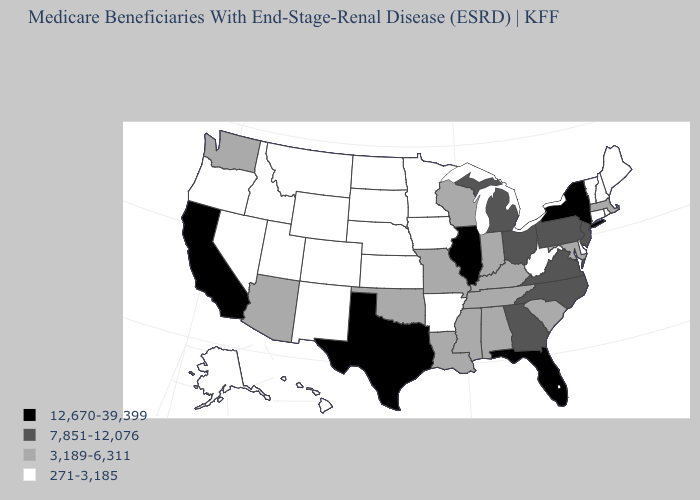Name the states that have a value in the range 271-3,185?
Concise answer only. Alaska, Arkansas, Colorado, Connecticut, Delaware, Hawaii, Idaho, Iowa, Kansas, Maine, Minnesota, Montana, Nebraska, Nevada, New Hampshire, New Mexico, North Dakota, Oregon, Rhode Island, South Dakota, Utah, Vermont, West Virginia, Wyoming. Does Oregon have the lowest value in the West?
Answer briefly. Yes. Is the legend a continuous bar?
Short answer required. No. Does the first symbol in the legend represent the smallest category?
Keep it brief. No. Among the states that border Wisconsin , does Iowa have the lowest value?
Keep it brief. Yes. What is the value of Missouri?
Be succinct. 3,189-6,311. Which states have the lowest value in the USA?
Answer briefly. Alaska, Arkansas, Colorado, Connecticut, Delaware, Hawaii, Idaho, Iowa, Kansas, Maine, Minnesota, Montana, Nebraska, Nevada, New Hampshire, New Mexico, North Dakota, Oregon, Rhode Island, South Dakota, Utah, Vermont, West Virginia, Wyoming. Is the legend a continuous bar?
Short answer required. No. What is the highest value in states that border Washington?
Short answer required. 271-3,185. Name the states that have a value in the range 271-3,185?
Write a very short answer. Alaska, Arkansas, Colorado, Connecticut, Delaware, Hawaii, Idaho, Iowa, Kansas, Maine, Minnesota, Montana, Nebraska, Nevada, New Hampshire, New Mexico, North Dakota, Oregon, Rhode Island, South Dakota, Utah, Vermont, West Virginia, Wyoming. Among the states that border Michigan , which have the lowest value?
Quick response, please. Indiana, Wisconsin. What is the lowest value in states that border Minnesota?
Short answer required. 271-3,185. What is the highest value in the USA?
Write a very short answer. 12,670-39,399. Does South Dakota have the lowest value in the MidWest?
Concise answer only. Yes. Which states have the lowest value in the USA?
Quick response, please. Alaska, Arkansas, Colorado, Connecticut, Delaware, Hawaii, Idaho, Iowa, Kansas, Maine, Minnesota, Montana, Nebraska, Nevada, New Hampshire, New Mexico, North Dakota, Oregon, Rhode Island, South Dakota, Utah, Vermont, West Virginia, Wyoming. 